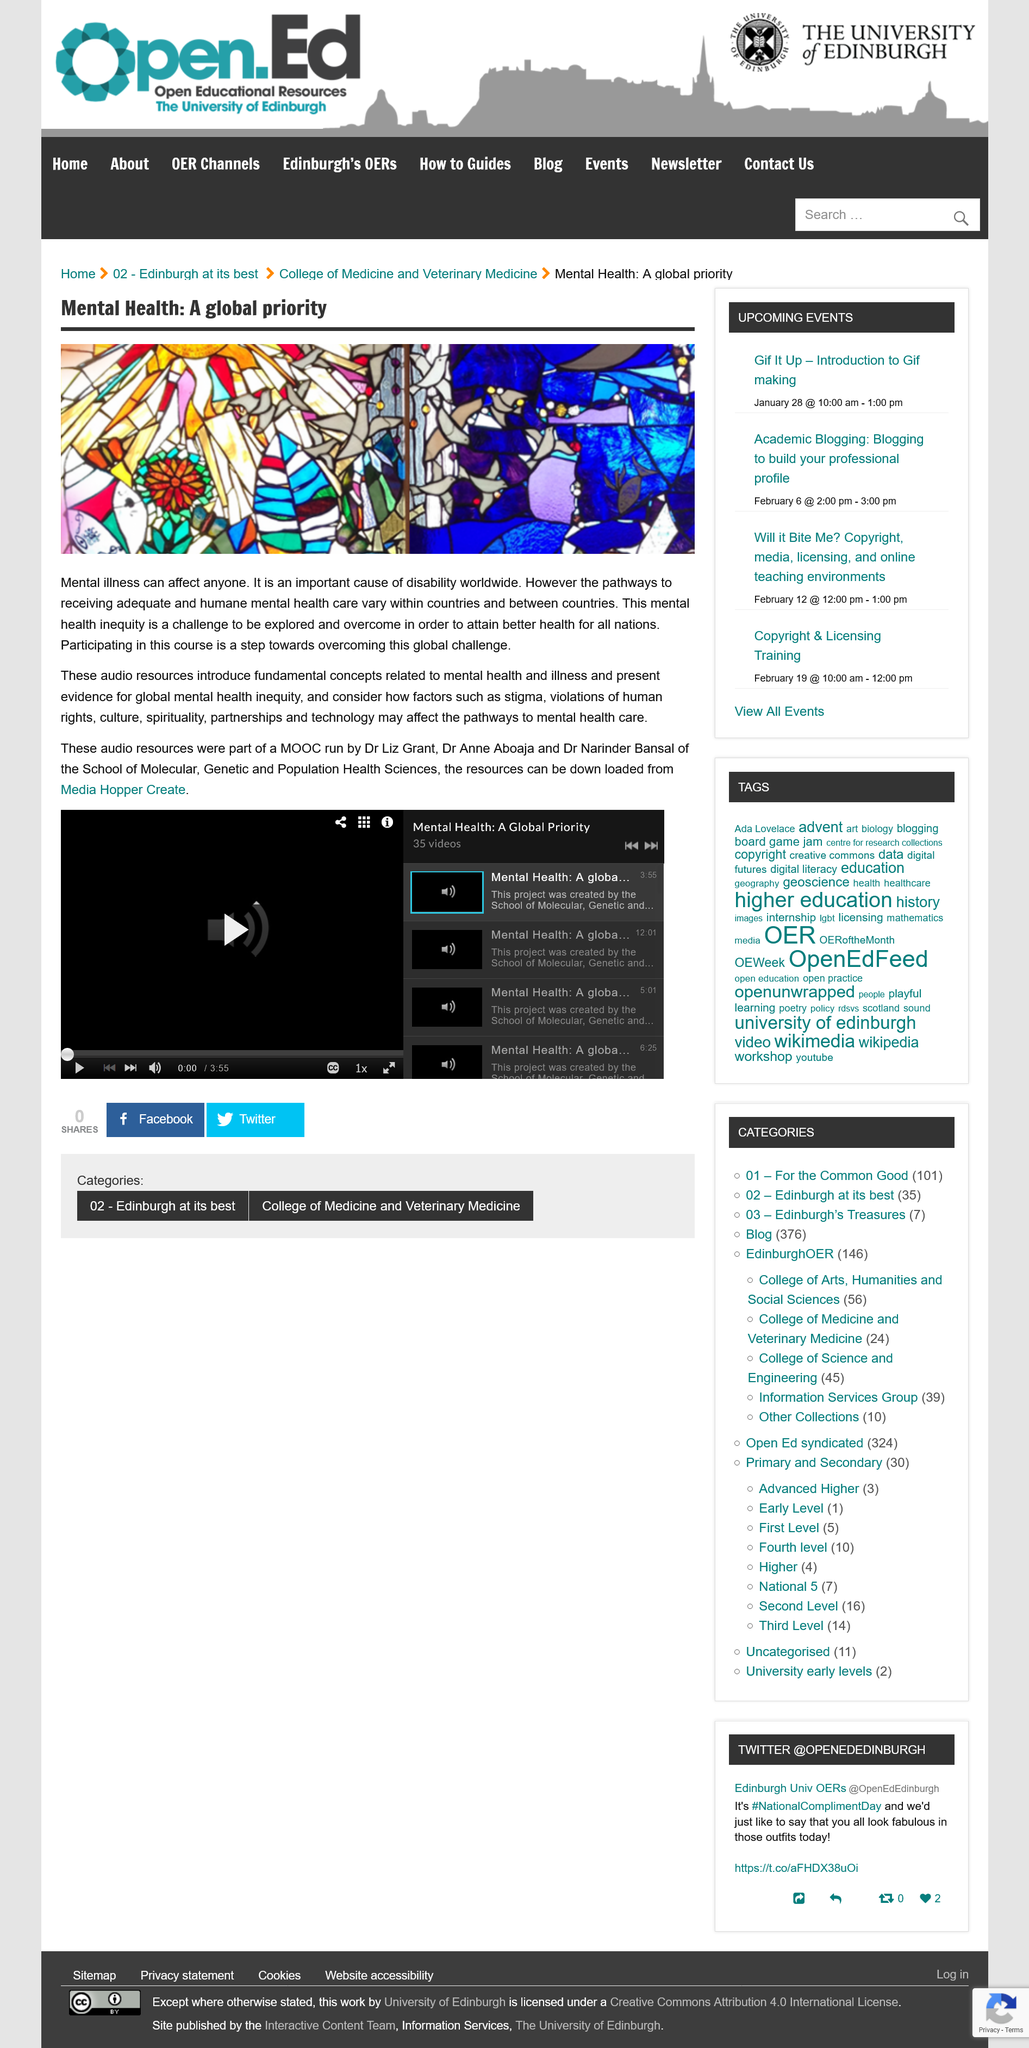Identify some key points in this picture. The audio resources are taking into account various factors, such as stigma, violations of human rights, culture, spirituality, partnerships, and technology, that can impact the pathways to mental health care. This article refers to audio resources in addition to the other resources mentioned in the article. The acronym of the program that the audio resources were a part of is MOOC. 